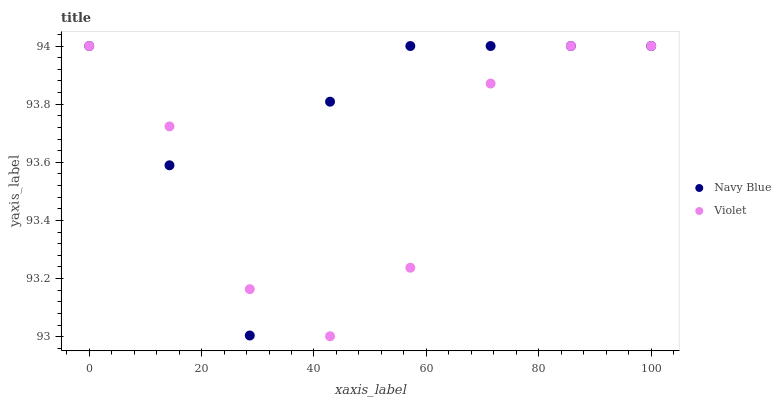Does Violet have the minimum area under the curve?
Answer yes or no. Yes. Does Navy Blue have the maximum area under the curve?
Answer yes or no. Yes. Does Violet have the maximum area under the curve?
Answer yes or no. No. Is Violet the smoothest?
Answer yes or no. Yes. Is Navy Blue the roughest?
Answer yes or no. Yes. Is Violet the roughest?
Answer yes or no. No. Does Violet have the lowest value?
Answer yes or no. Yes. Does Violet have the highest value?
Answer yes or no. Yes. Does Violet intersect Navy Blue?
Answer yes or no. Yes. Is Violet less than Navy Blue?
Answer yes or no. No. Is Violet greater than Navy Blue?
Answer yes or no. No. 